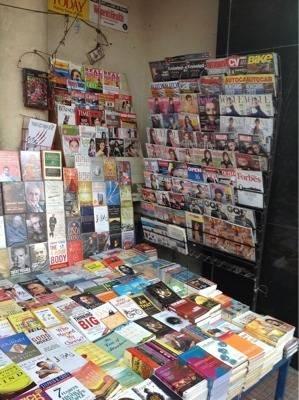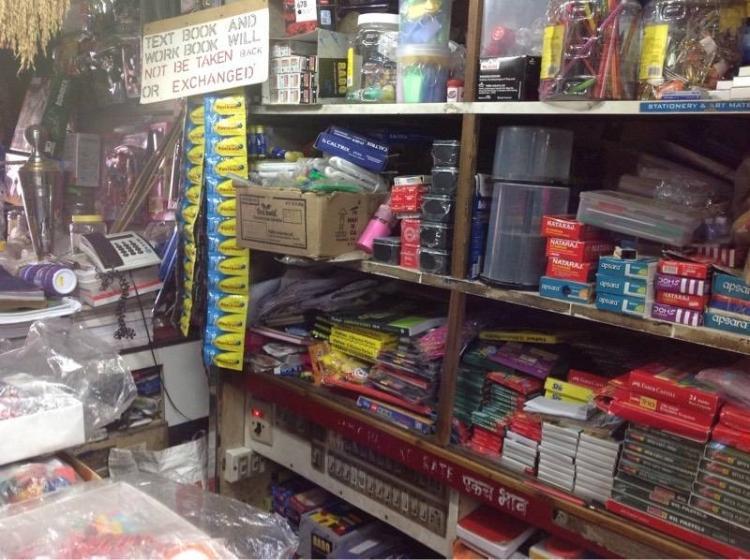The first image is the image on the left, the second image is the image on the right. Analyze the images presented: Is the assertion "There is at least one person that is walking in a bookstore near a light brown bookshelf." valid? Answer yes or no. No. The first image is the image on the left, the second image is the image on the right. Analyze the images presented: Is the assertion "The shops are empty." valid? Answer yes or no. Yes. 